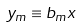<formula> <loc_0><loc_0><loc_500><loc_500>y _ { m } \equiv b _ { m } x</formula> 